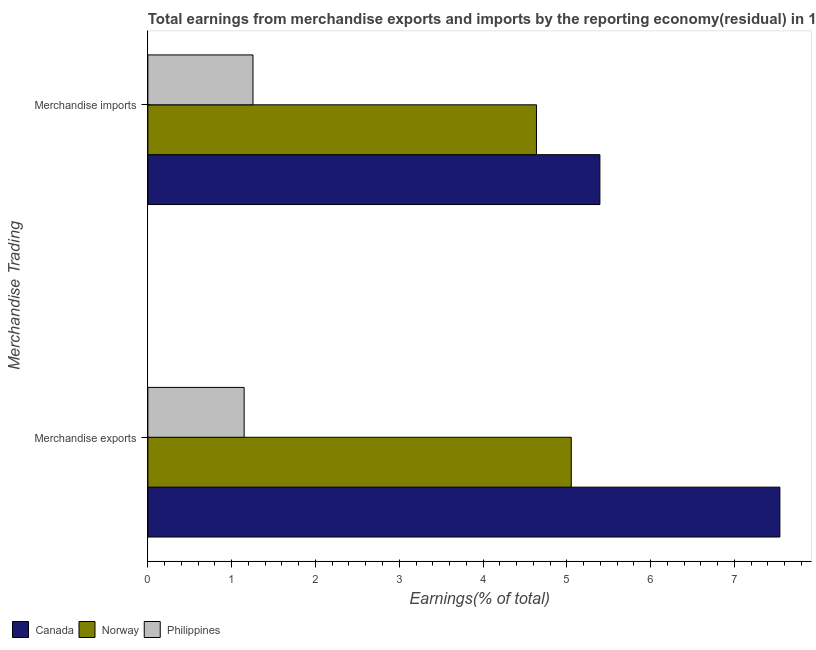How many different coloured bars are there?
Give a very brief answer. 3. Are the number of bars on each tick of the Y-axis equal?
Keep it short and to the point. Yes. How many bars are there on the 2nd tick from the top?
Give a very brief answer. 3. How many bars are there on the 1st tick from the bottom?
Offer a terse response. 3. What is the earnings from merchandise exports in Norway?
Your answer should be very brief. 5.05. Across all countries, what is the maximum earnings from merchandise exports?
Provide a succinct answer. 7.54. Across all countries, what is the minimum earnings from merchandise exports?
Make the answer very short. 1.15. In which country was the earnings from merchandise exports maximum?
Provide a succinct answer. Canada. What is the total earnings from merchandise exports in the graph?
Make the answer very short. 13.74. What is the difference between the earnings from merchandise imports in Norway and that in Canada?
Your response must be concise. -0.76. What is the difference between the earnings from merchandise imports in Norway and the earnings from merchandise exports in Canada?
Keep it short and to the point. -2.91. What is the average earnings from merchandise imports per country?
Provide a short and direct response. 3.76. What is the difference between the earnings from merchandise exports and earnings from merchandise imports in Canada?
Keep it short and to the point. 2.15. In how many countries, is the earnings from merchandise exports greater than 3 %?
Provide a succinct answer. 2. What is the ratio of the earnings from merchandise imports in Philippines to that in Canada?
Provide a succinct answer. 0.23. Is the earnings from merchandise imports in Canada less than that in Norway?
Make the answer very short. No. What does the 3rd bar from the top in Merchandise exports represents?
Your response must be concise. Canada. Are all the bars in the graph horizontal?
Your response must be concise. Yes. How many countries are there in the graph?
Make the answer very short. 3. What is the difference between two consecutive major ticks on the X-axis?
Ensure brevity in your answer.  1. Are the values on the major ticks of X-axis written in scientific E-notation?
Provide a short and direct response. No. Does the graph contain any zero values?
Offer a terse response. No. What is the title of the graph?
Provide a short and direct response. Total earnings from merchandise exports and imports by the reporting economy(residual) in 1974. Does "Czech Republic" appear as one of the legend labels in the graph?
Your answer should be compact. No. What is the label or title of the X-axis?
Keep it short and to the point. Earnings(% of total). What is the label or title of the Y-axis?
Provide a succinct answer. Merchandise Trading. What is the Earnings(% of total) of Canada in Merchandise exports?
Make the answer very short. 7.54. What is the Earnings(% of total) in Norway in Merchandise exports?
Ensure brevity in your answer.  5.05. What is the Earnings(% of total) of Philippines in Merchandise exports?
Make the answer very short. 1.15. What is the Earnings(% of total) of Canada in Merchandise imports?
Provide a short and direct response. 5.39. What is the Earnings(% of total) of Norway in Merchandise imports?
Offer a very short reply. 4.64. What is the Earnings(% of total) of Philippines in Merchandise imports?
Your answer should be very brief. 1.25. Across all Merchandise Trading, what is the maximum Earnings(% of total) in Canada?
Give a very brief answer. 7.54. Across all Merchandise Trading, what is the maximum Earnings(% of total) of Norway?
Your answer should be very brief. 5.05. Across all Merchandise Trading, what is the maximum Earnings(% of total) in Philippines?
Offer a terse response. 1.25. Across all Merchandise Trading, what is the minimum Earnings(% of total) of Canada?
Your answer should be very brief. 5.39. Across all Merchandise Trading, what is the minimum Earnings(% of total) of Norway?
Ensure brevity in your answer.  4.64. Across all Merchandise Trading, what is the minimum Earnings(% of total) in Philippines?
Give a very brief answer. 1.15. What is the total Earnings(% of total) in Canada in the graph?
Offer a very short reply. 12.94. What is the total Earnings(% of total) in Norway in the graph?
Your answer should be very brief. 9.69. What is the total Earnings(% of total) in Philippines in the graph?
Your answer should be compact. 2.4. What is the difference between the Earnings(% of total) of Canada in Merchandise exports and that in Merchandise imports?
Your answer should be compact. 2.15. What is the difference between the Earnings(% of total) of Norway in Merchandise exports and that in Merchandise imports?
Provide a succinct answer. 0.42. What is the difference between the Earnings(% of total) in Philippines in Merchandise exports and that in Merchandise imports?
Ensure brevity in your answer.  -0.11. What is the difference between the Earnings(% of total) of Canada in Merchandise exports and the Earnings(% of total) of Norway in Merchandise imports?
Offer a very short reply. 2.9. What is the difference between the Earnings(% of total) in Canada in Merchandise exports and the Earnings(% of total) in Philippines in Merchandise imports?
Your answer should be very brief. 6.29. What is the difference between the Earnings(% of total) in Norway in Merchandise exports and the Earnings(% of total) in Philippines in Merchandise imports?
Your response must be concise. 3.8. What is the average Earnings(% of total) of Canada per Merchandise Trading?
Offer a very short reply. 6.47. What is the average Earnings(% of total) in Norway per Merchandise Trading?
Your answer should be compact. 4.85. What is the average Earnings(% of total) in Philippines per Merchandise Trading?
Ensure brevity in your answer.  1.2. What is the difference between the Earnings(% of total) of Canada and Earnings(% of total) of Norway in Merchandise exports?
Provide a succinct answer. 2.49. What is the difference between the Earnings(% of total) of Canada and Earnings(% of total) of Philippines in Merchandise exports?
Offer a terse response. 6.39. What is the difference between the Earnings(% of total) of Norway and Earnings(% of total) of Philippines in Merchandise exports?
Offer a very short reply. 3.9. What is the difference between the Earnings(% of total) of Canada and Earnings(% of total) of Norway in Merchandise imports?
Ensure brevity in your answer.  0.76. What is the difference between the Earnings(% of total) of Canada and Earnings(% of total) of Philippines in Merchandise imports?
Provide a succinct answer. 4.14. What is the difference between the Earnings(% of total) of Norway and Earnings(% of total) of Philippines in Merchandise imports?
Offer a very short reply. 3.38. What is the ratio of the Earnings(% of total) of Canada in Merchandise exports to that in Merchandise imports?
Make the answer very short. 1.4. What is the ratio of the Earnings(% of total) of Norway in Merchandise exports to that in Merchandise imports?
Your response must be concise. 1.09. What is the ratio of the Earnings(% of total) in Philippines in Merchandise exports to that in Merchandise imports?
Give a very brief answer. 0.92. What is the difference between the highest and the second highest Earnings(% of total) of Canada?
Your response must be concise. 2.15. What is the difference between the highest and the second highest Earnings(% of total) in Norway?
Give a very brief answer. 0.42. What is the difference between the highest and the second highest Earnings(% of total) in Philippines?
Offer a very short reply. 0.11. What is the difference between the highest and the lowest Earnings(% of total) of Canada?
Offer a terse response. 2.15. What is the difference between the highest and the lowest Earnings(% of total) in Norway?
Ensure brevity in your answer.  0.42. What is the difference between the highest and the lowest Earnings(% of total) in Philippines?
Make the answer very short. 0.11. 